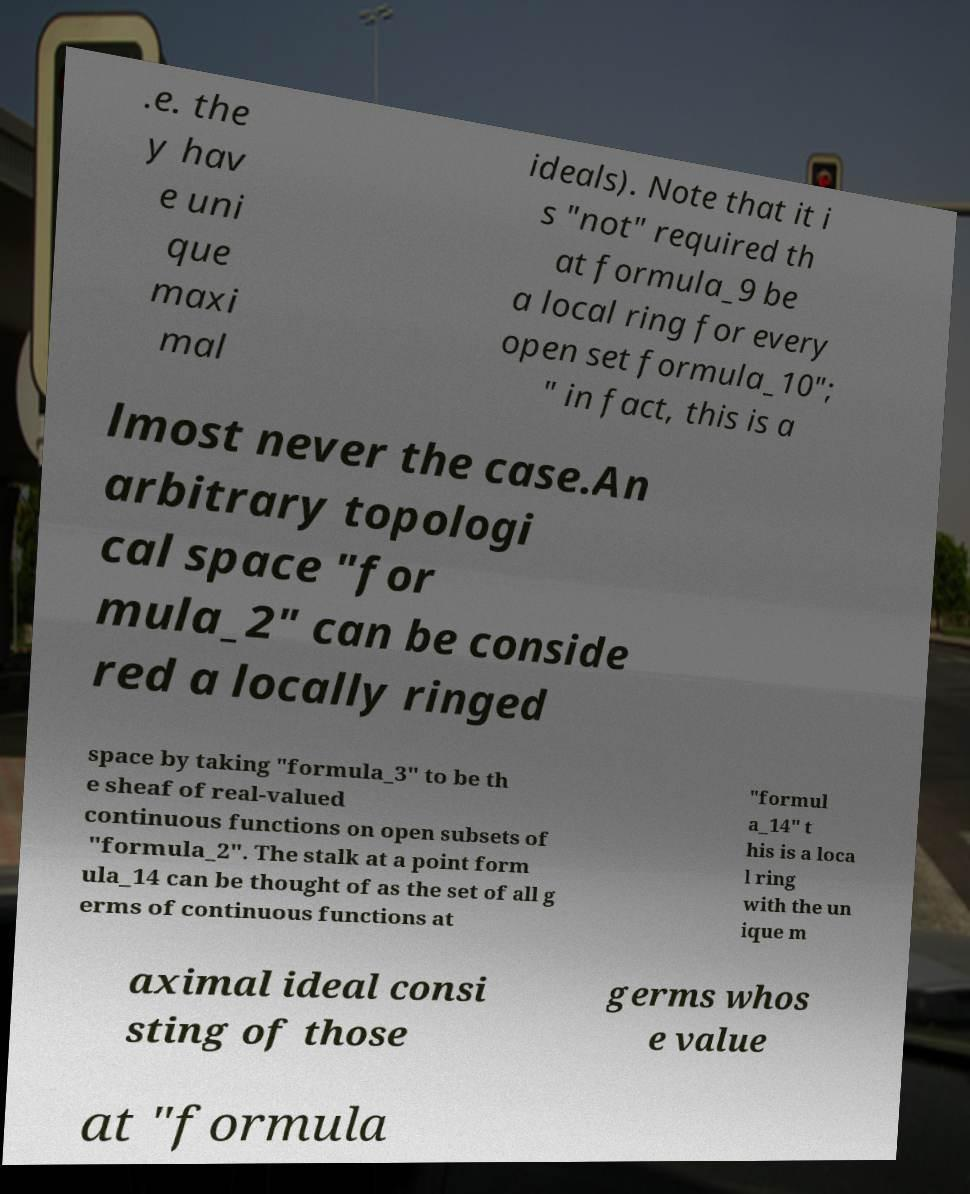Can you accurately transcribe the text from the provided image for me? .e. the y hav e uni que maxi mal ideals). Note that it i s "not" required th at formula_9 be a local ring for every open set formula_10"; " in fact, this is a lmost never the case.An arbitrary topologi cal space "for mula_2" can be conside red a locally ringed space by taking "formula_3" to be th e sheaf of real-valued continuous functions on open subsets of "formula_2". The stalk at a point form ula_14 can be thought of as the set of all g erms of continuous functions at "formul a_14" t his is a loca l ring with the un ique m aximal ideal consi sting of those germs whos e value at "formula 